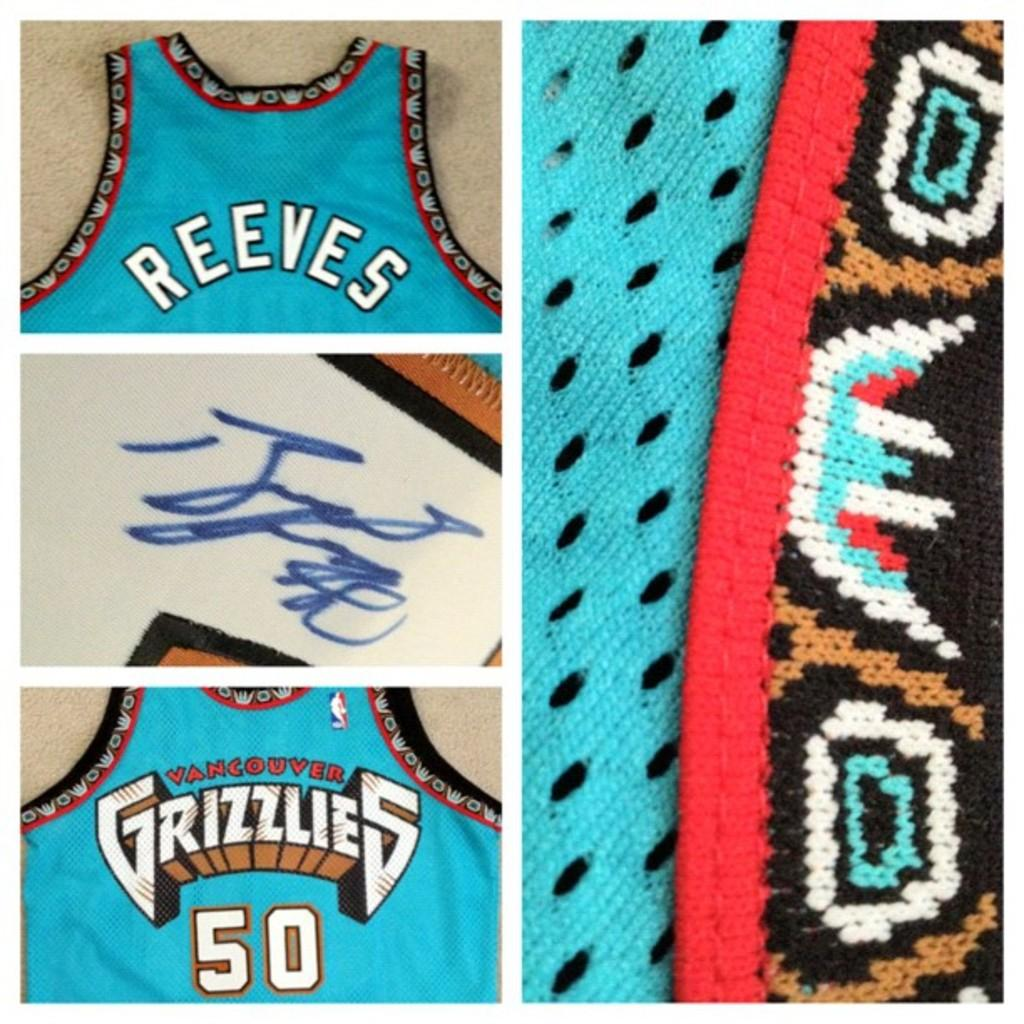Provide a one-sentence caption for the provided image. A jersey of Reeves with a signature from the team Grizzlies. 